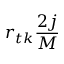<formula> <loc_0><loc_0><loc_500><loc_500>r _ { t k } \frac { 2 j } { M }</formula> 